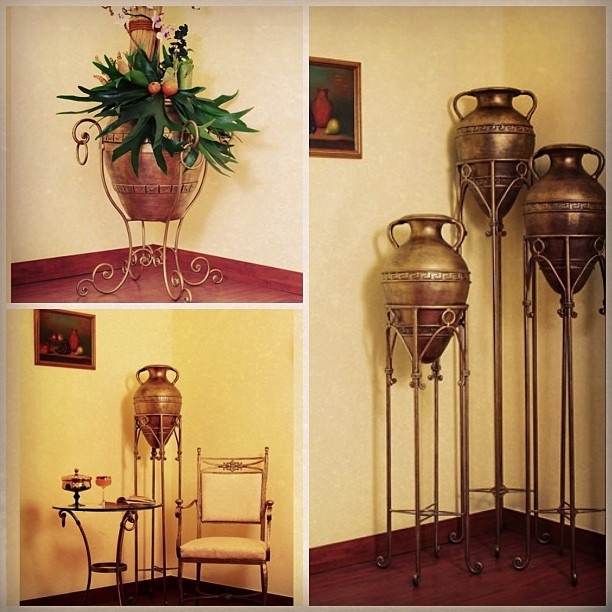Describe the objects in this image and their specific colors. I can see vase in tan, black, maroon, and gray tones, potted plant in tan, black, darkgreen, and maroon tones, vase in tan, maroon, black, and brown tones, vase in tan, brown, maroon, and gray tones, and chair in tan, red, and maroon tones in this image. 